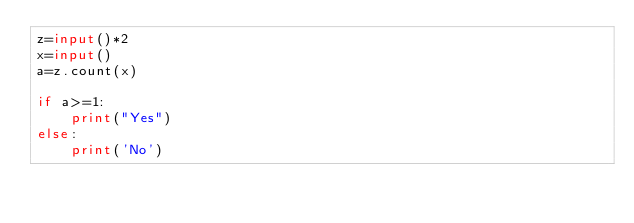<code> <loc_0><loc_0><loc_500><loc_500><_Python_>z=input()*2
x=input()
a=z.count(x)

if a>=1:
    print("Yes")
else:
    print('No')</code> 